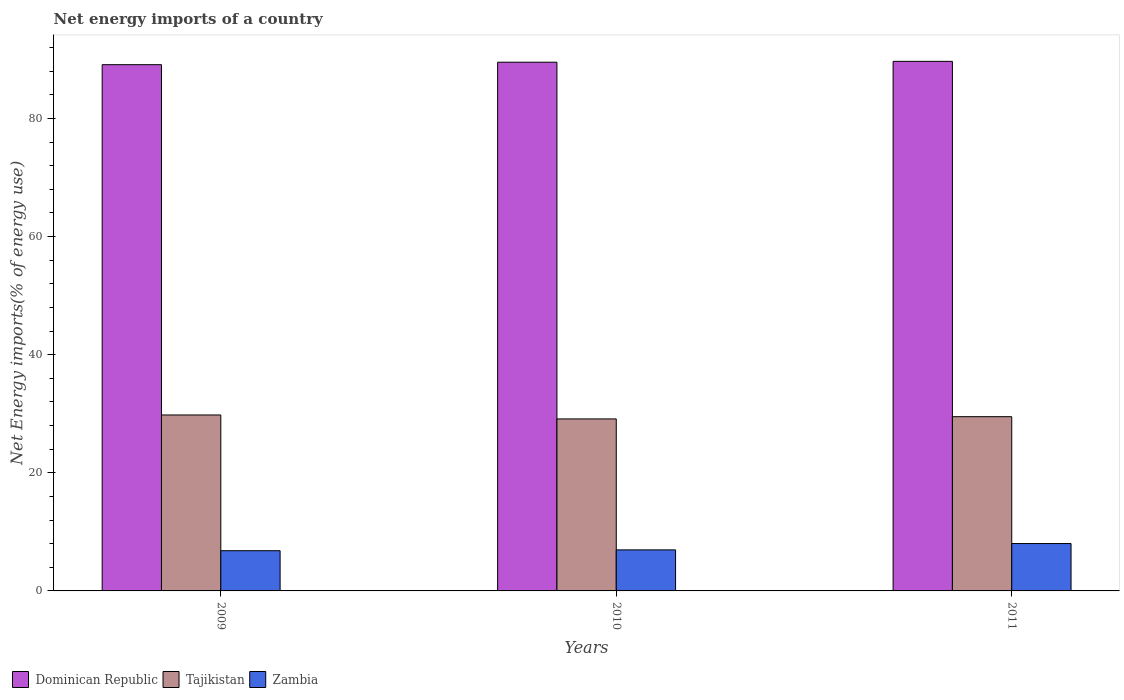Are the number of bars on each tick of the X-axis equal?
Keep it short and to the point. Yes. How many bars are there on the 2nd tick from the left?
Offer a terse response. 3. What is the net energy imports in Zambia in 2009?
Provide a succinct answer. 6.81. Across all years, what is the maximum net energy imports in Dominican Republic?
Provide a short and direct response. 89.67. Across all years, what is the minimum net energy imports in Zambia?
Your answer should be compact. 6.81. In which year was the net energy imports in Zambia minimum?
Give a very brief answer. 2009. What is the total net energy imports in Zambia in the graph?
Make the answer very short. 21.78. What is the difference between the net energy imports in Tajikistan in 2009 and that in 2011?
Provide a short and direct response. 0.29. What is the difference between the net energy imports in Dominican Republic in 2010 and the net energy imports in Tajikistan in 2009?
Keep it short and to the point. 59.73. What is the average net energy imports in Zambia per year?
Make the answer very short. 7.26. In the year 2009, what is the difference between the net energy imports in Dominican Republic and net energy imports in Zambia?
Provide a succinct answer. 82.3. In how many years, is the net energy imports in Zambia greater than 48 %?
Offer a terse response. 0. What is the ratio of the net energy imports in Dominican Republic in 2009 to that in 2011?
Your answer should be compact. 0.99. Is the net energy imports in Tajikistan in 2010 less than that in 2011?
Provide a short and direct response. Yes. Is the difference between the net energy imports in Dominican Republic in 2009 and 2011 greater than the difference between the net energy imports in Zambia in 2009 and 2011?
Provide a short and direct response. Yes. What is the difference between the highest and the second highest net energy imports in Dominican Republic?
Give a very brief answer. 0.15. What is the difference between the highest and the lowest net energy imports in Tajikistan?
Give a very brief answer. 0.67. In how many years, is the net energy imports in Tajikistan greater than the average net energy imports in Tajikistan taken over all years?
Ensure brevity in your answer.  2. Is the sum of the net energy imports in Tajikistan in 2009 and 2010 greater than the maximum net energy imports in Dominican Republic across all years?
Provide a succinct answer. No. What does the 3rd bar from the left in 2010 represents?
Your answer should be compact. Zambia. What does the 2nd bar from the right in 2009 represents?
Provide a short and direct response. Tajikistan. Is it the case that in every year, the sum of the net energy imports in Zambia and net energy imports in Dominican Republic is greater than the net energy imports in Tajikistan?
Offer a terse response. Yes. How many years are there in the graph?
Your response must be concise. 3. What is the difference between two consecutive major ticks on the Y-axis?
Ensure brevity in your answer.  20. Are the values on the major ticks of Y-axis written in scientific E-notation?
Give a very brief answer. No. Does the graph contain any zero values?
Your answer should be compact. No. Does the graph contain grids?
Offer a very short reply. No. Where does the legend appear in the graph?
Your answer should be very brief. Bottom left. How many legend labels are there?
Offer a very short reply. 3. What is the title of the graph?
Provide a short and direct response. Net energy imports of a country. What is the label or title of the X-axis?
Offer a terse response. Years. What is the label or title of the Y-axis?
Provide a short and direct response. Net Energy imports(% of energy use). What is the Net Energy imports(% of energy use) in Dominican Republic in 2009?
Your answer should be very brief. 89.1. What is the Net Energy imports(% of energy use) in Tajikistan in 2009?
Provide a short and direct response. 29.79. What is the Net Energy imports(% of energy use) in Zambia in 2009?
Your answer should be very brief. 6.81. What is the Net Energy imports(% of energy use) in Dominican Republic in 2010?
Your response must be concise. 89.52. What is the Net Energy imports(% of energy use) of Tajikistan in 2010?
Ensure brevity in your answer.  29.12. What is the Net Energy imports(% of energy use) in Zambia in 2010?
Make the answer very short. 6.95. What is the Net Energy imports(% of energy use) of Dominican Republic in 2011?
Offer a very short reply. 89.67. What is the Net Energy imports(% of energy use) in Tajikistan in 2011?
Give a very brief answer. 29.5. What is the Net Energy imports(% of energy use) in Zambia in 2011?
Your answer should be compact. 8.02. Across all years, what is the maximum Net Energy imports(% of energy use) of Dominican Republic?
Your response must be concise. 89.67. Across all years, what is the maximum Net Energy imports(% of energy use) in Tajikistan?
Provide a succinct answer. 29.79. Across all years, what is the maximum Net Energy imports(% of energy use) of Zambia?
Offer a terse response. 8.02. Across all years, what is the minimum Net Energy imports(% of energy use) of Dominican Republic?
Keep it short and to the point. 89.1. Across all years, what is the minimum Net Energy imports(% of energy use) of Tajikistan?
Offer a very short reply. 29.12. Across all years, what is the minimum Net Energy imports(% of energy use) in Zambia?
Provide a short and direct response. 6.81. What is the total Net Energy imports(% of energy use) of Dominican Republic in the graph?
Give a very brief answer. 268.29. What is the total Net Energy imports(% of energy use) in Tajikistan in the graph?
Ensure brevity in your answer.  88.42. What is the total Net Energy imports(% of energy use) of Zambia in the graph?
Give a very brief answer. 21.78. What is the difference between the Net Energy imports(% of energy use) in Dominican Republic in 2009 and that in 2010?
Offer a very short reply. -0.42. What is the difference between the Net Energy imports(% of energy use) in Tajikistan in 2009 and that in 2010?
Keep it short and to the point. 0.67. What is the difference between the Net Energy imports(% of energy use) of Zambia in 2009 and that in 2010?
Offer a very short reply. -0.14. What is the difference between the Net Energy imports(% of energy use) in Dominican Republic in 2009 and that in 2011?
Your answer should be compact. -0.56. What is the difference between the Net Energy imports(% of energy use) in Tajikistan in 2009 and that in 2011?
Provide a short and direct response. 0.29. What is the difference between the Net Energy imports(% of energy use) in Zambia in 2009 and that in 2011?
Offer a terse response. -1.21. What is the difference between the Net Energy imports(% of energy use) of Dominican Republic in 2010 and that in 2011?
Your response must be concise. -0.15. What is the difference between the Net Energy imports(% of energy use) in Tajikistan in 2010 and that in 2011?
Offer a very short reply. -0.38. What is the difference between the Net Energy imports(% of energy use) in Zambia in 2010 and that in 2011?
Keep it short and to the point. -1.08. What is the difference between the Net Energy imports(% of energy use) of Dominican Republic in 2009 and the Net Energy imports(% of energy use) of Tajikistan in 2010?
Provide a succinct answer. 59.98. What is the difference between the Net Energy imports(% of energy use) in Dominican Republic in 2009 and the Net Energy imports(% of energy use) in Zambia in 2010?
Ensure brevity in your answer.  82.16. What is the difference between the Net Energy imports(% of energy use) of Tajikistan in 2009 and the Net Energy imports(% of energy use) of Zambia in 2010?
Offer a very short reply. 22.84. What is the difference between the Net Energy imports(% of energy use) in Dominican Republic in 2009 and the Net Energy imports(% of energy use) in Tajikistan in 2011?
Your answer should be very brief. 59.6. What is the difference between the Net Energy imports(% of energy use) of Dominican Republic in 2009 and the Net Energy imports(% of energy use) of Zambia in 2011?
Your response must be concise. 81.08. What is the difference between the Net Energy imports(% of energy use) of Tajikistan in 2009 and the Net Energy imports(% of energy use) of Zambia in 2011?
Ensure brevity in your answer.  21.77. What is the difference between the Net Energy imports(% of energy use) of Dominican Republic in 2010 and the Net Energy imports(% of energy use) of Tajikistan in 2011?
Offer a terse response. 60.02. What is the difference between the Net Energy imports(% of energy use) in Dominican Republic in 2010 and the Net Energy imports(% of energy use) in Zambia in 2011?
Give a very brief answer. 81.5. What is the difference between the Net Energy imports(% of energy use) of Tajikistan in 2010 and the Net Energy imports(% of energy use) of Zambia in 2011?
Make the answer very short. 21.1. What is the average Net Energy imports(% of energy use) in Dominican Republic per year?
Keep it short and to the point. 89.43. What is the average Net Energy imports(% of energy use) of Tajikistan per year?
Provide a succinct answer. 29.47. What is the average Net Energy imports(% of energy use) in Zambia per year?
Your response must be concise. 7.26. In the year 2009, what is the difference between the Net Energy imports(% of energy use) of Dominican Republic and Net Energy imports(% of energy use) of Tajikistan?
Give a very brief answer. 59.31. In the year 2009, what is the difference between the Net Energy imports(% of energy use) in Dominican Republic and Net Energy imports(% of energy use) in Zambia?
Keep it short and to the point. 82.3. In the year 2009, what is the difference between the Net Energy imports(% of energy use) in Tajikistan and Net Energy imports(% of energy use) in Zambia?
Provide a short and direct response. 22.98. In the year 2010, what is the difference between the Net Energy imports(% of energy use) in Dominican Republic and Net Energy imports(% of energy use) in Tajikistan?
Keep it short and to the point. 60.4. In the year 2010, what is the difference between the Net Energy imports(% of energy use) of Dominican Republic and Net Energy imports(% of energy use) of Zambia?
Provide a short and direct response. 82.57. In the year 2010, what is the difference between the Net Energy imports(% of energy use) in Tajikistan and Net Energy imports(% of energy use) in Zambia?
Provide a succinct answer. 22.17. In the year 2011, what is the difference between the Net Energy imports(% of energy use) of Dominican Republic and Net Energy imports(% of energy use) of Tajikistan?
Ensure brevity in your answer.  60.16. In the year 2011, what is the difference between the Net Energy imports(% of energy use) in Dominican Republic and Net Energy imports(% of energy use) in Zambia?
Provide a short and direct response. 81.64. In the year 2011, what is the difference between the Net Energy imports(% of energy use) of Tajikistan and Net Energy imports(% of energy use) of Zambia?
Provide a succinct answer. 21.48. What is the ratio of the Net Energy imports(% of energy use) of Tajikistan in 2009 to that in 2010?
Offer a very short reply. 1.02. What is the ratio of the Net Energy imports(% of energy use) in Zambia in 2009 to that in 2010?
Provide a succinct answer. 0.98. What is the ratio of the Net Energy imports(% of energy use) in Tajikistan in 2009 to that in 2011?
Your answer should be compact. 1.01. What is the ratio of the Net Energy imports(% of energy use) of Zambia in 2009 to that in 2011?
Your response must be concise. 0.85. What is the ratio of the Net Energy imports(% of energy use) in Tajikistan in 2010 to that in 2011?
Ensure brevity in your answer.  0.99. What is the ratio of the Net Energy imports(% of energy use) of Zambia in 2010 to that in 2011?
Ensure brevity in your answer.  0.87. What is the difference between the highest and the second highest Net Energy imports(% of energy use) in Dominican Republic?
Your answer should be very brief. 0.15. What is the difference between the highest and the second highest Net Energy imports(% of energy use) of Tajikistan?
Provide a short and direct response. 0.29. What is the difference between the highest and the second highest Net Energy imports(% of energy use) of Zambia?
Give a very brief answer. 1.08. What is the difference between the highest and the lowest Net Energy imports(% of energy use) of Dominican Republic?
Give a very brief answer. 0.56. What is the difference between the highest and the lowest Net Energy imports(% of energy use) in Tajikistan?
Your answer should be very brief. 0.67. What is the difference between the highest and the lowest Net Energy imports(% of energy use) of Zambia?
Your answer should be very brief. 1.21. 